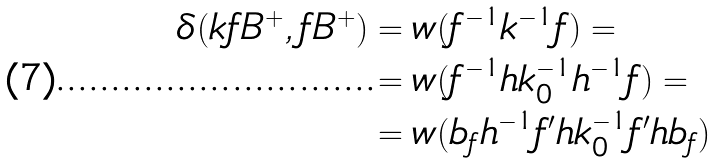<formula> <loc_0><loc_0><loc_500><loc_500>\delta ( k f B ^ { + } , f B ^ { + } ) & = w ( f ^ { - 1 } k ^ { - 1 } f ) = \\ & = w ( f ^ { - 1 } h k _ { 0 } ^ { - 1 } h ^ { - 1 } f ) = \\ & = w ( b _ { f } h ^ { - 1 } f ^ { \prime } h k _ { 0 } ^ { - 1 } f ^ { \prime } h b _ { f } )</formula> 